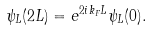Convert formula to latex. <formula><loc_0><loc_0><loc_500><loc_500>\psi _ { L } ( 2 L ) = e ^ { 2 i k _ { F } L } \psi _ { L } ( 0 ) .</formula> 